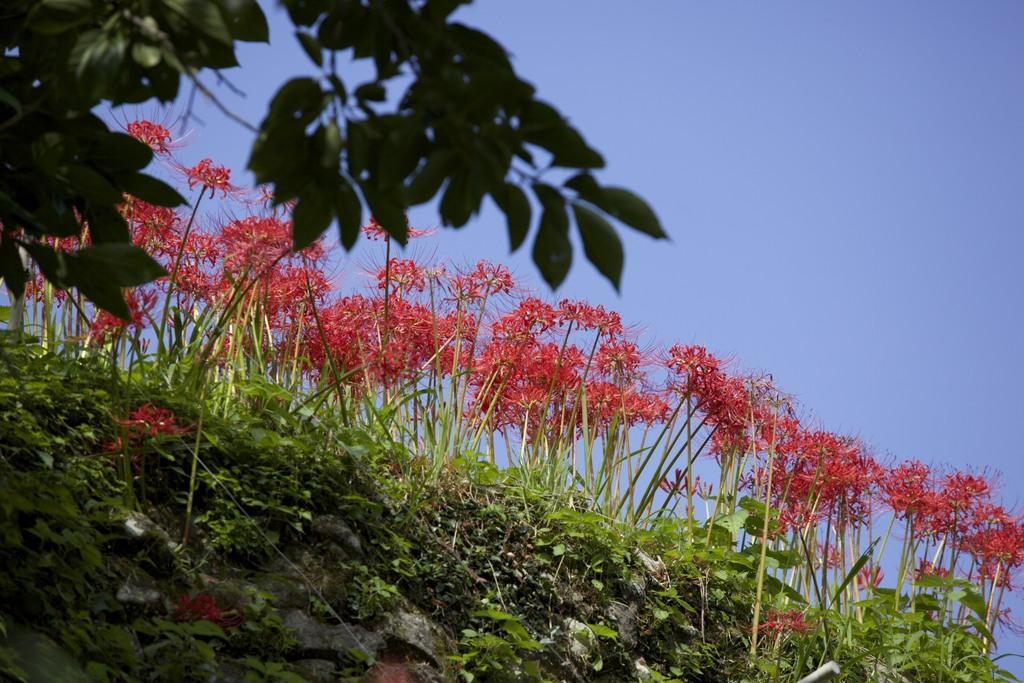Describe this image in one or two sentences. In this image I can see grass and number of red colour flowers. On the top left side of this image I can see number of green colour leaves and in the background I can see the sky. 